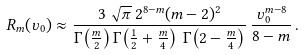Convert formula to latex. <formula><loc_0><loc_0><loc_500><loc_500>R _ { m } ( \upsilon _ { 0 } ) \approx \frac { 3 \, \sqrt { \pi } \, 2 ^ { 8 - m } ( m - 2 ) ^ { 2 } } { \Gamma { \left ( \frac { m } { 2 } \right ) } \, \Gamma { \left ( \frac { 1 } { 2 } + \frac { m } { 4 } \right ) \, \Gamma { \left ( 2 - \frac { m } { 4 } \right ) } } } \, \frac { \upsilon _ { 0 } ^ { m - 8 } } { 8 - m } \, .</formula> 